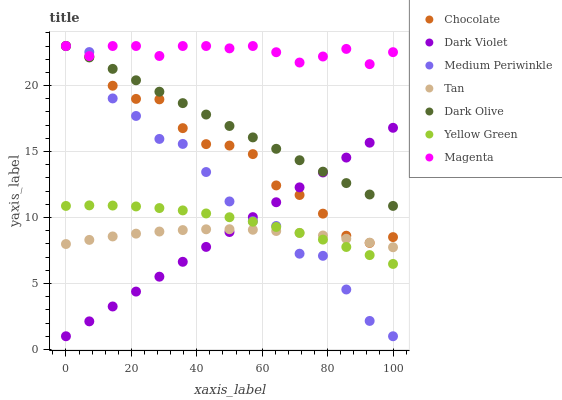Does Tan have the minimum area under the curve?
Answer yes or no. Yes. Does Magenta have the maximum area under the curve?
Answer yes or no. Yes. Does Dark Olive have the minimum area under the curve?
Answer yes or no. No. Does Dark Olive have the maximum area under the curve?
Answer yes or no. No. Is Dark Olive the smoothest?
Answer yes or no. Yes. Is Medium Periwinkle the roughest?
Answer yes or no. Yes. Is Medium Periwinkle the smoothest?
Answer yes or no. No. Is Dark Olive the roughest?
Answer yes or no. No. Does Medium Periwinkle have the lowest value?
Answer yes or no. Yes. Does Dark Olive have the lowest value?
Answer yes or no. No. Does Magenta have the highest value?
Answer yes or no. Yes. Does Dark Violet have the highest value?
Answer yes or no. No. Is Tan less than Magenta?
Answer yes or no. Yes. Is Dark Olive greater than Yellow Green?
Answer yes or no. Yes. Does Tan intersect Dark Violet?
Answer yes or no. Yes. Is Tan less than Dark Violet?
Answer yes or no. No. Is Tan greater than Dark Violet?
Answer yes or no. No. Does Tan intersect Magenta?
Answer yes or no. No. 